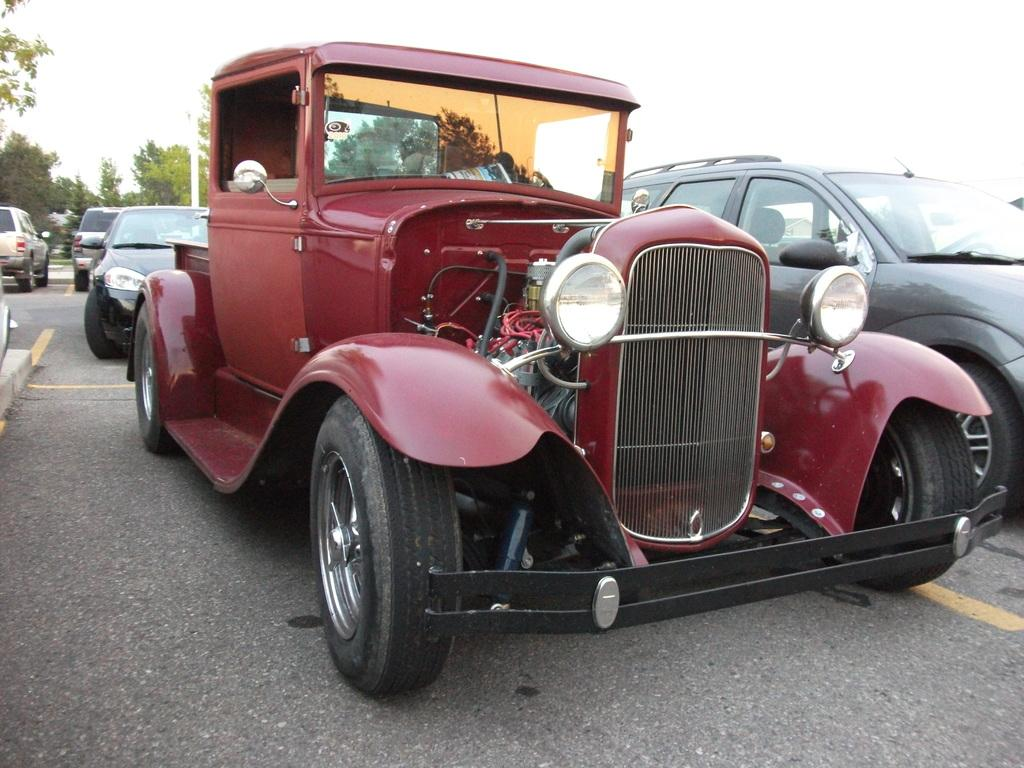What can be seen on the road in the image? There are vehicles on the road in the image. What type of natural elements are visible in the background of the image? There are trees in the background of the image. What else can be seen in the background of the image? There is a pole in the background of the image. What is visible above the pole and trees in the image? The sky is visible in the background of the image. Can you tell me how many lawyers are sitting on the pole in the image? There are no lawyers present in the image, and the pole does not have any seats for them to sit on. 